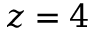<formula> <loc_0><loc_0><loc_500><loc_500>z = 4</formula> 